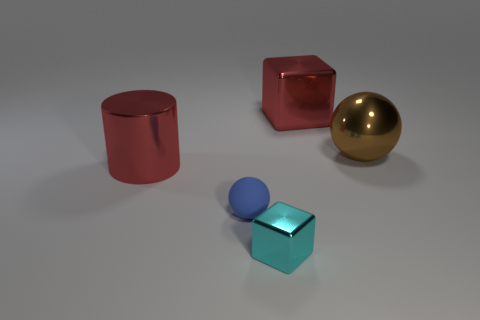What can you infer about the environment where these objects are placed? The objects are placed on a smooth surface with a slight reflection, indicating it's likely a polished floor, typical of an indoor setting. The absence of any distinct background elements or context means that the environment is neutral, possibly intended to focus attention solely on the objects themselves. 